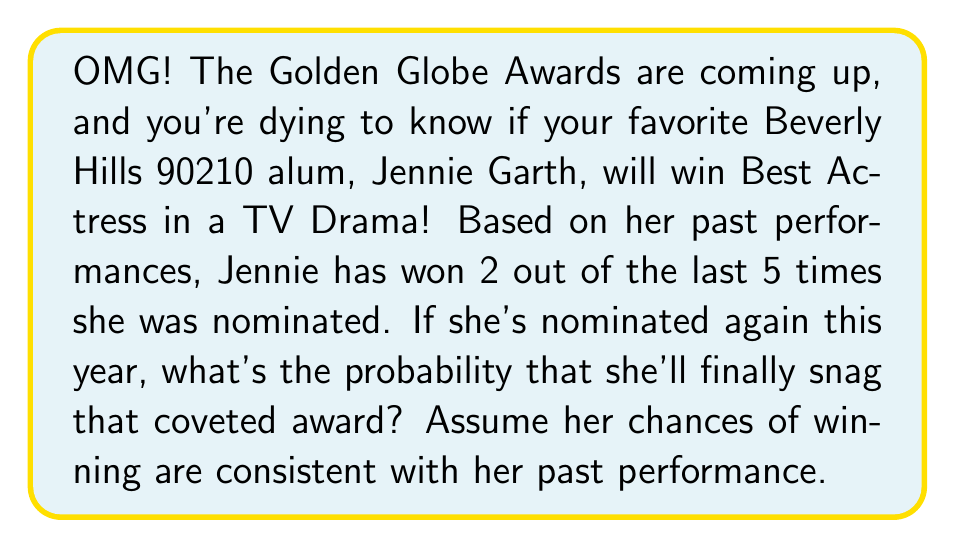Can you answer this question? Let's break this down with some celebrity-worthy math!

1) First, we need to determine Jennie's win rate based on her past performances:
   
   $\text{Win rate} = \frac{\text{Number of wins}}{\text{Number of nominations}} = \frac{2}{5} = 0.4$ or 40%

2) Now, we're assuming that her chances of winning in the upcoming awards are consistent with this past performance. In probability terms, this means that the probability of her winning is equal to her win rate.

3) Therefore, the probability of Jennie winning the award this year is:

   $P(\text{Jennie wins}) = 0.4$ or 40%

4) We can also express this as a fraction:

   $P(\text{Jennie wins}) = \frac{2}{5}$

This means that if the awards were held many times under the same conditions, we would expect Jennie to win about 40% of the time in the long run.

Remember, each award show is an independent event, so past wins don't guarantee future success. But based on her track record, Jennie has a pretty good shot at bringing home that Golden Globe!
Answer: The probability that Jennie Garth will win the award is $\frac{2}{5}$ or 0.4 or 40%. 